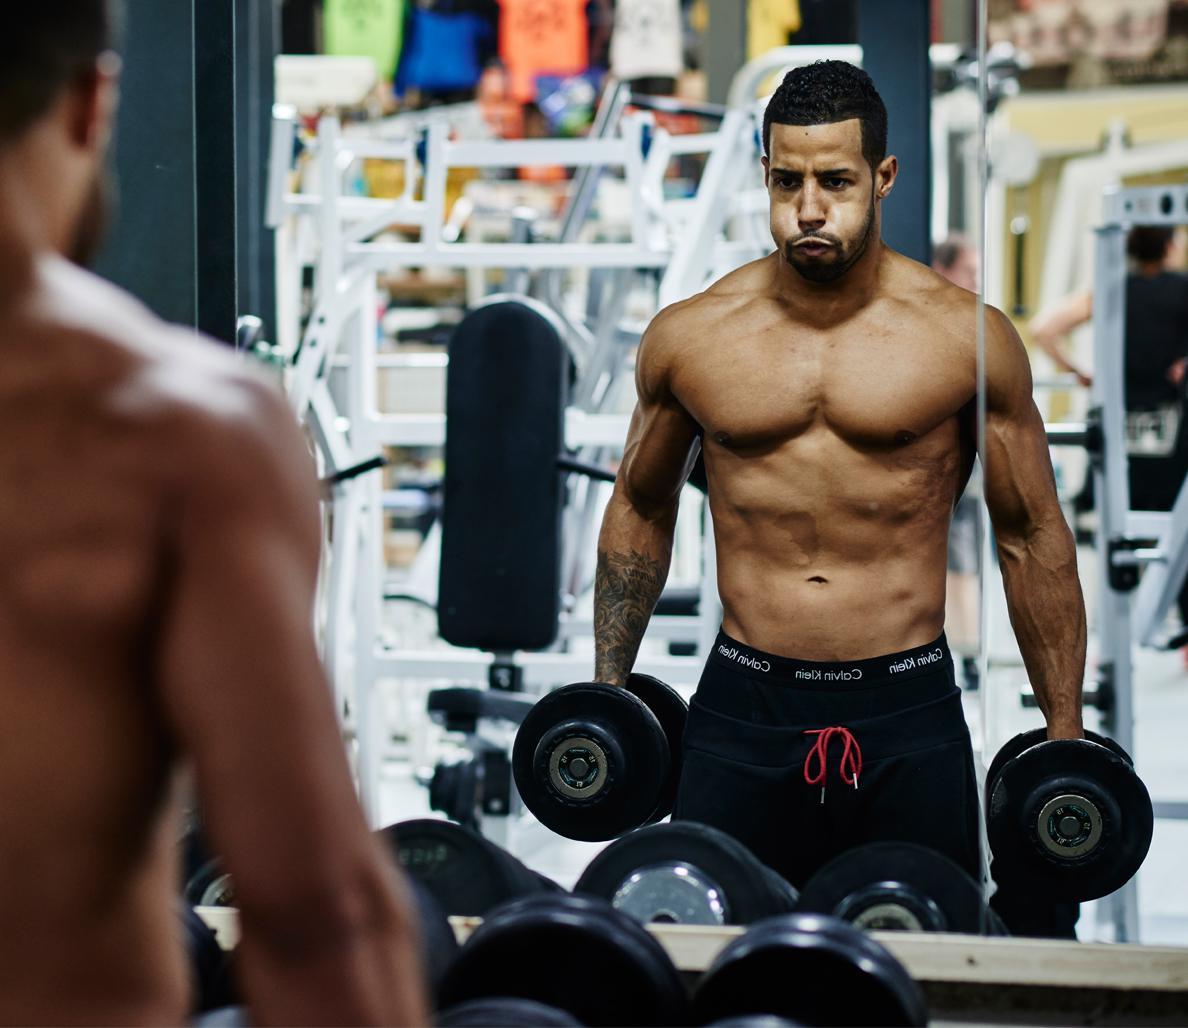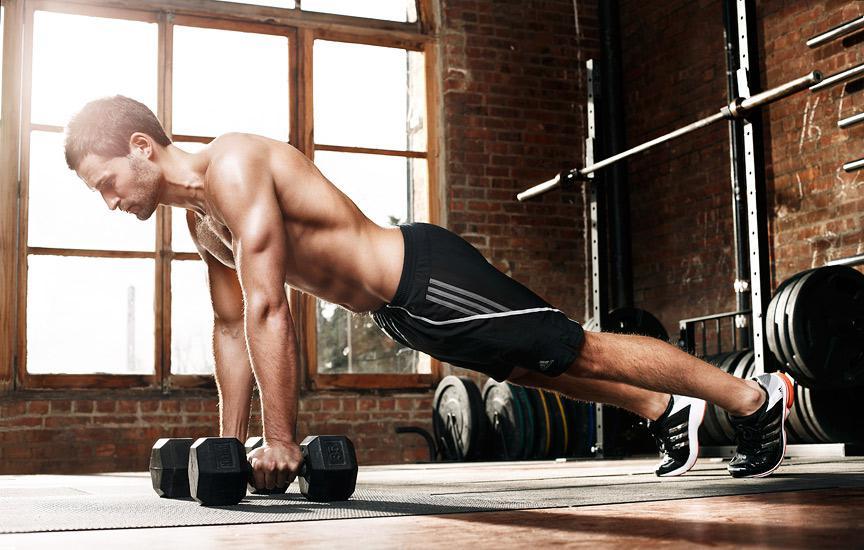The first image is the image on the left, the second image is the image on the right. Assess this claim about the two images: "In one image a bodybuilder, facing the floor, is balanced on the toes of his feet and has at least one hand on the floor gripping a small barbell.". Correct or not? Answer yes or no. Yes. The first image is the image on the left, the second image is the image on the right. For the images shown, is this caption "An image shows a man grasping weights and facing the floor, with body extended horizontally plank-style." true? Answer yes or no. Yes. 